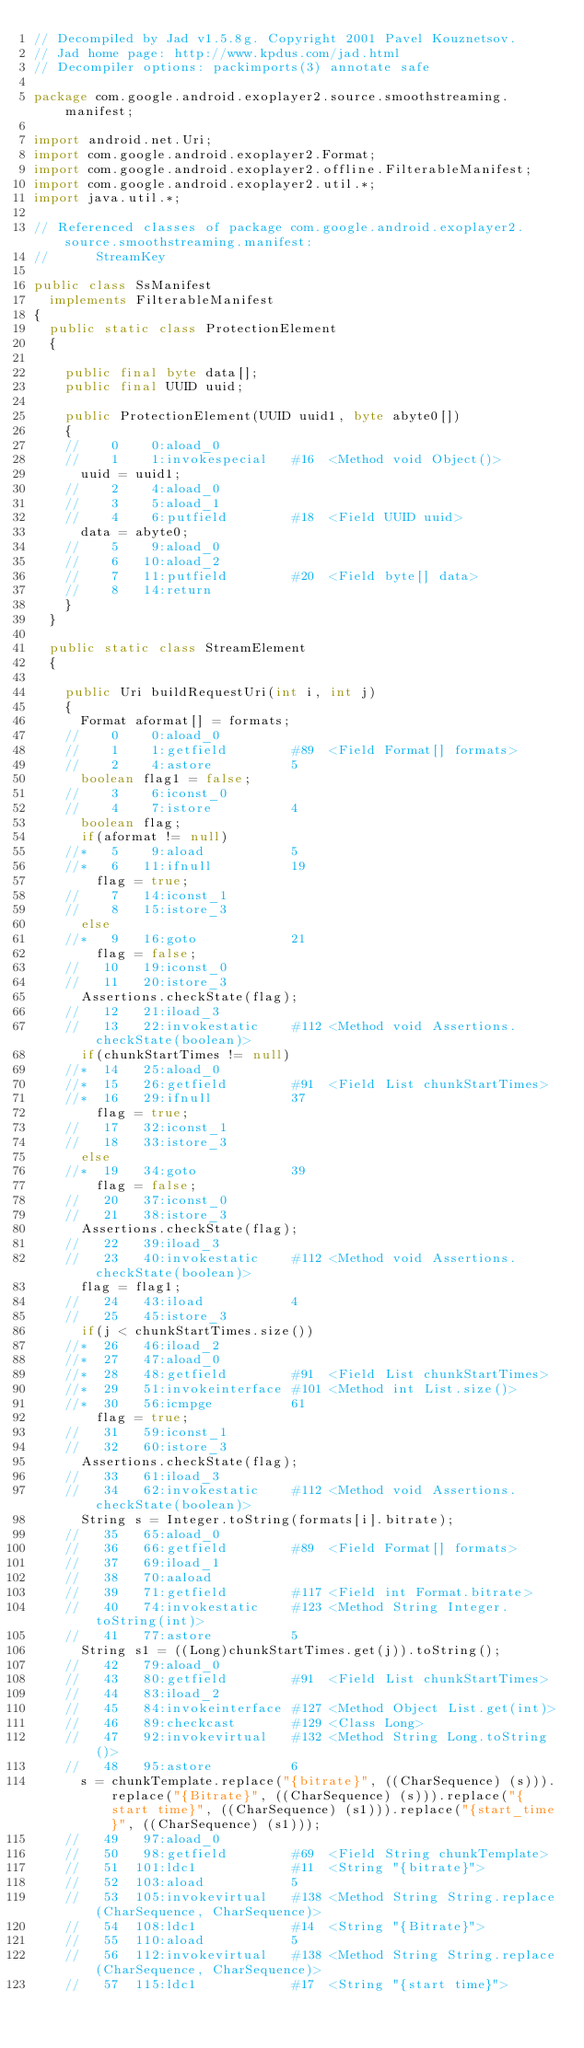Convert code to text. <code><loc_0><loc_0><loc_500><loc_500><_Java_>// Decompiled by Jad v1.5.8g. Copyright 2001 Pavel Kouznetsov.
// Jad home page: http://www.kpdus.com/jad.html
// Decompiler options: packimports(3) annotate safe 

package com.google.android.exoplayer2.source.smoothstreaming.manifest;

import android.net.Uri;
import com.google.android.exoplayer2.Format;
import com.google.android.exoplayer2.offline.FilterableManifest;
import com.google.android.exoplayer2.util.*;
import java.util.*;

// Referenced classes of package com.google.android.exoplayer2.source.smoothstreaming.manifest:
//			StreamKey

public class SsManifest
	implements FilterableManifest
{
	public static class ProtectionElement
	{

		public final byte data[];
		public final UUID uuid;

		public ProtectionElement(UUID uuid1, byte abyte0[])
		{
		//    0    0:aload_0         
		//    1    1:invokespecial   #16  <Method void Object()>
			uuid = uuid1;
		//    2    4:aload_0         
		//    3    5:aload_1         
		//    4    6:putfield        #18  <Field UUID uuid>
			data = abyte0;
		//    5    9:aload_0         
		//    6   10:aload_2         
		//    7   11:putfield        #20  <Field byte[] data>
		//    8   14:return          
		}
	}

	public static class StreamElement
	{

		public Uri buildRequestUri(int i, int j)
		{
			Format aformat[] = formats;
		//    0    0:aload_0         
		//    1    1:getfield        #89  <Field Format[] formats>
		//    2    4:astore          5
			boolean flag1 = false;
		//    3    6:iconst_0        
		//    4    7:istore          4
			boolean flag;
			if(aformat != null)
		//*   5    9:aload           5
		//*   6   11:ifnull          19
				flag = true;
		//    7   14:iconst_1        
		//    8   15:istore_3        
			else
		//*   9   16:goto            21
				flag = false;
		//   10   19:iconst_0        
		//   11   20:istore_3        
			Assertions.checkState(flag);
		//   12   21:iload_3         
		//   13   22:invokestatic    #112 <Method void Assertions.checkState(boolean)>
			if(chunkStartTimes != null)
		//*  14   25:aload_0         
		//*  15   26:getfield        #91  <Field List chunkStartTimes>
		//*  16   29:ifnull          37
				flag = true;
		//   17   32:iconst_1        
		//   18   33:istore_3        
			else
		//*  19   34:goto            39
				flag = false;
		//   20   37:iconst_0        
		//   21   38:istore_3        
			Assertions.checkState(flag);
		//   22   39:iload_3         
		//   23   40:invokestatic    #112 <Method void Assertions.checkState(boolean)>
			flag = flag1;
		//   24   43:iload           4
		//   25   45:istore_3        
			if(j < chunkStartTimes.size())
		//*  26   46:iload_2         
		//*  27   47:aload_0         
		//*  28   48:getfield        #91  <Field List chunkStartTimes>
		//*  29   51:invokeinterface #101 <Method int List.size()>
		//*  30   56:icmpge          61
				flag = true;
		//   31   59:iconst_1        
		//   32   60:istore_3        
			Assertions.checkState(flag);
		//   33   61:iload_3         
		//   34   62:invokestatic    #112 <Method void Assertions.checkState(boolean)>
			String s = Integer.toString(formats[i].bitrate);
		//   35   65:aload_0         
		//   36   66:getfield        #89  <Field Format[] formats>
		//   37   69:iload_1         
		//   38   70:aaload          
		//   39   71:getfield        #117 <Field int Format.bitrate>
		//   40   74:invokestatic    #123 <Method String Integer.toString(int)>
		//   41   77:astore          5
			String s1 = ((Long)chunkStartTimes.get(j)).toString();
		//   42   79:aload_0         
		//   43   80:getfield        #91  <Field List chunkStartTimes>
		//   44   83:iload_2         
		//   45   84:invokeinterface #127 <Method Object List.get(int)>
		//   46   89:checkcast       #129 <Class Long>
		//   47   92:invokevirtual   #132 <Method String Long.toString()>
		//   48   95:astore          6
			s = chunkTemplate.replace("{bitrate}", ((CharSequence) (s))).replace("{Bitrate}", ((CharSequence) (s))).replace("{start time}", ((CharSequence) (s1))).replace("{start_time}", ((CharSequence) (s1)));
		//   49   97:aload_0         
		//   50   98:getfield        #69  <Field String chunkTemplate>
		//   51  101:ldc1            #11  <String "{bitrate}">
		//   52  103:aload           5
		//   53  105:invokevirtual   #138 <Method String String.replace(CharSequence, CharSequence)>
		//   54  108:ldc1            #14  <String "{Bitrate}">
		//   55  110:aload           5
		//   56  112:invokevirtual   #138 <Method String String.replace(CharSequence, CharSequence)>
		//   57  115:ldc1            #17  <String "{start time}"></code> 